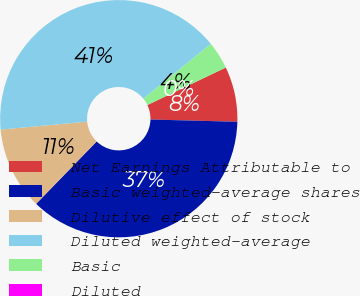Convert chart. <chart><loc_0><loc_0><loc_500><loc_500><pie_chart><fcel>Net Earnings Attributable to<fcel>Basic weighted-average shares<fcel>Dilutive effect of stock<fcel>Diluted weighted-average<fcel>Basic<fcel>Diluted<nl><fcel>7.51%<fcel>36.85%<fcel>11.27%<fcel>40.61%<fcel>3.76%<fcel>0.0%<nl></chart> 